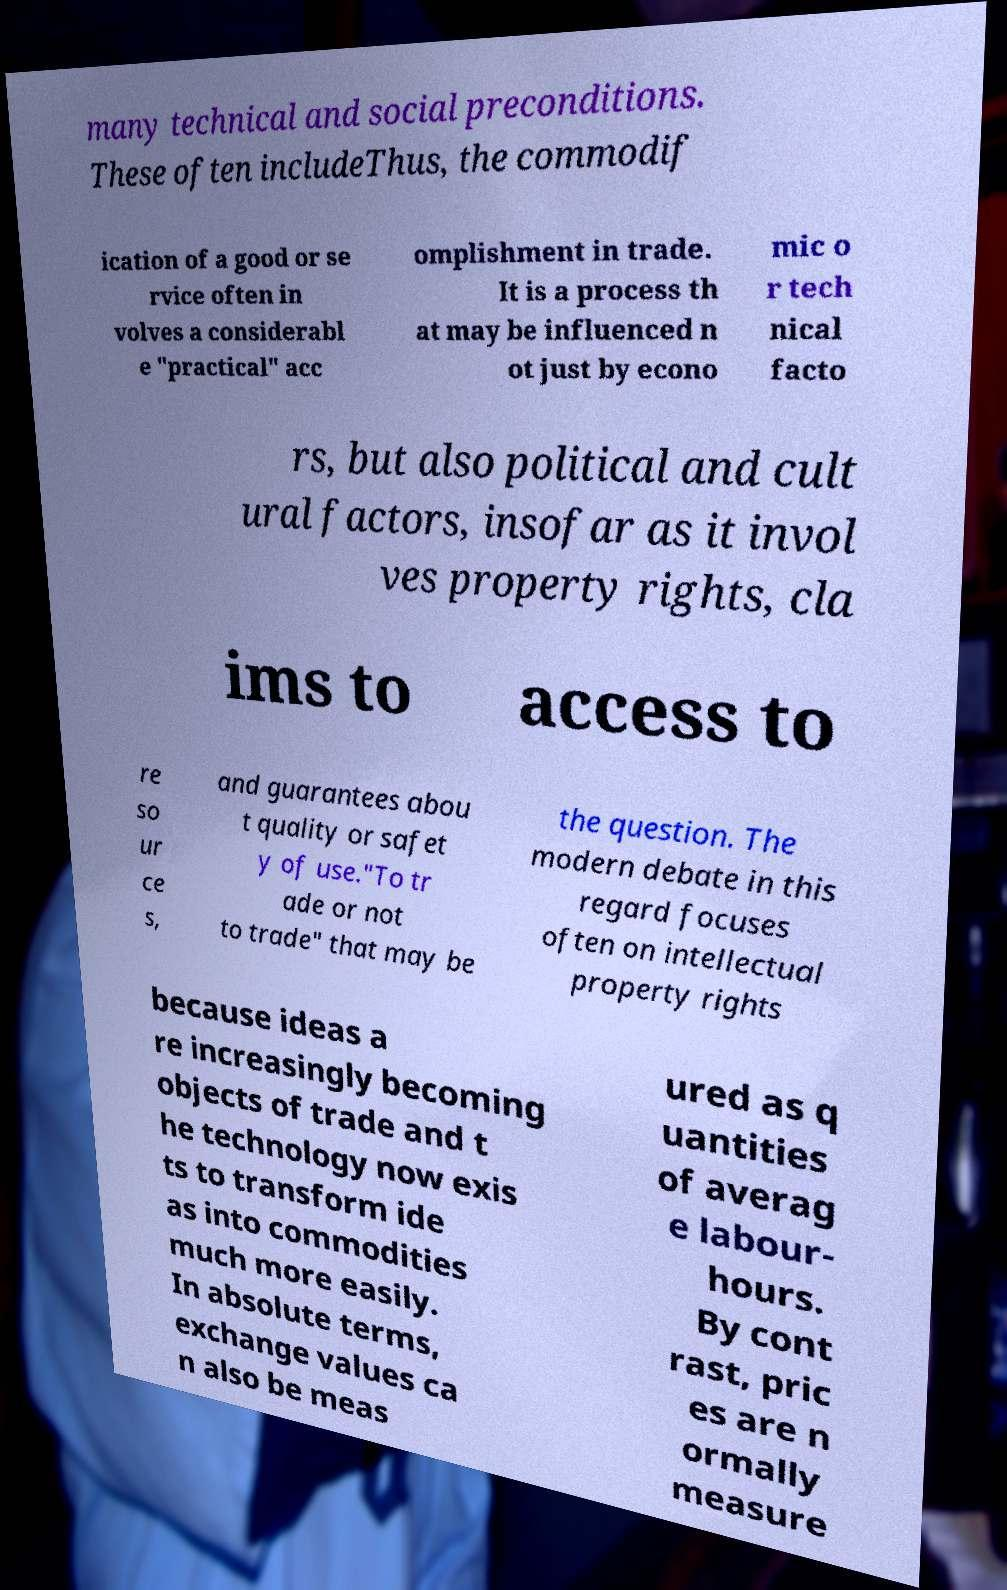Please identify and transcribe the text found in this image. many technical and social preconditions. These often includeThus, the commodif ication of a good or se rvice often in volves a considerabl e "practical" acc omplishment in trade. It is a process th at may be influenced n ot just by econo mic o r tech nical facto rs, but also political and cult ural factors, insofar as it invol ves property rights, cla ims to access to re so ur ce s, and guarantees abou t quality or safet y of use."To tr ade or not to trade" that may be the question. The modern debate in this regard focuses often on intellectual property rights because ideas a re increasingly becoming objects of trade and t he technology now exis ts to transform ide as into commodities much more easily. In absolute terms, exchange values ca n also be meas ured as q uantities of averag e labour- hours. By cont rast, pric es are n ormally measure 